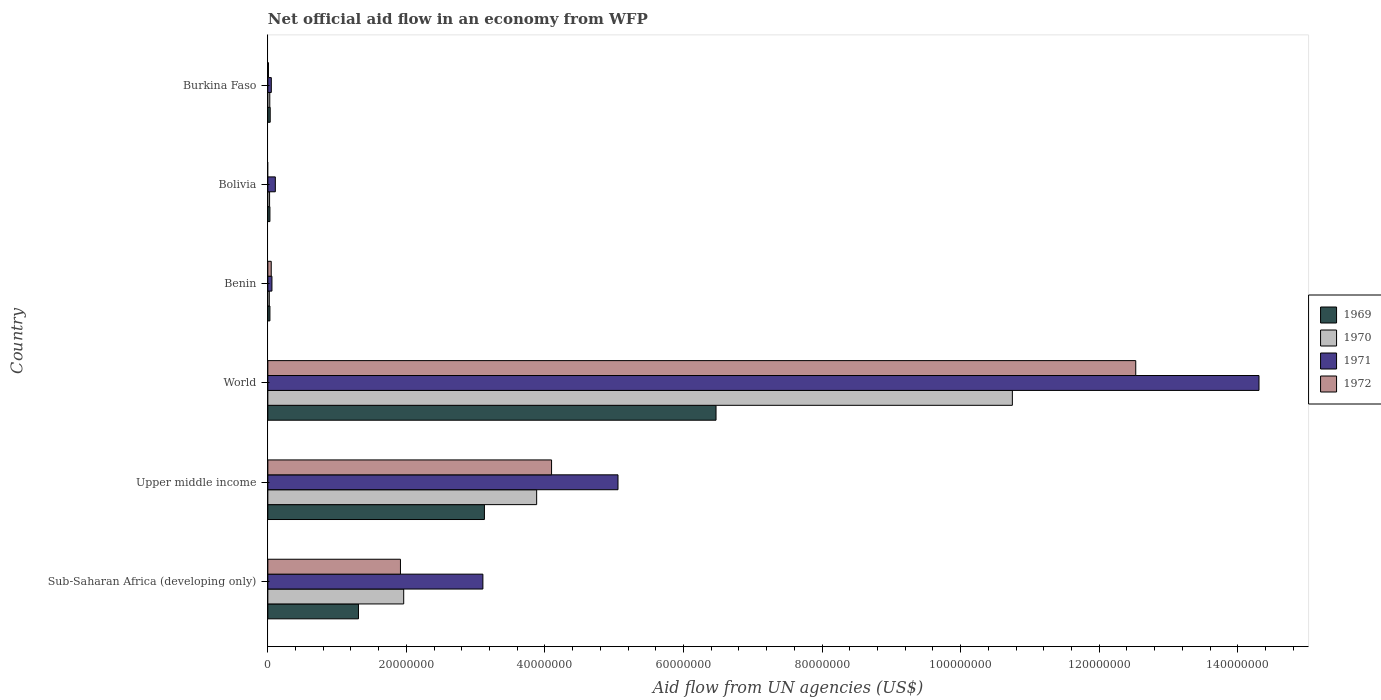How many different coloured bars are there?
Offer a very short reply. 4. How many groups of bars are there?
Provide a succinct answer. 6. Are the number of bars on each tick of the Y-axis equal?
Your answer should be compact. No. How many bars are there on the 3rd tick from the top?
Give a very brief answer. 4. How many bars are there on the 5th tick from the bottom?
Ensure brevity in your answer.  3. What is the label of the 6th group of bars from the top?
Keep it short and to the point. Sub-Saharan Africa (developing only). What is the net official aid flow in 1969 in Sub-Saharan Africa (developing only)?
Offer a very short reply. 1.31e+07. Across all countries, what is the maximum net official aid flow in 1972?
Keep it short and to the point. 1.25e+08. Across all countries, what is the minimum net official aid flow in 1972?
Your answer should be compact. 0. In which country was the net official aid flow in 1972 maximum?
Offer a very short reply. World. What is the total net official aid flow in 1972 in the graph?
Provide a short and direct response. 1.86e+08. What is the difference between the net official aid flow in 1971 in Sub-Saharan Africa (developing only) and that in World?
Your answer should be compact. -1.12e+08. What is the difference between the net official aid flow in 1971 in Bolivia and the net official aid flow in 1970 in Benin?
Ensure brevity in your answer.  8.70e+05. What is the average net official aid flow in 1972 per country?
Give a very brief answer. 3.10e+07. What is the difference between the net official aid flow in 1971 and net official aid flow in 1972 in World?
Keep it short and to the point. 1.78e+07. In how many countries, is the net official aid flow in 1969 greater than 136000000 US$?
Your answer should be compact. 0. What is the ratio of the net official aid flow in 1969 in Bolivia to that in Upper middle income?
Provide a succinct answer. 0.01. Is the net official aid flow in 1969 in Sub-Saharan Africa (developing only) less than that in Upper middle income?
Offer a very short reply. Yes. Is the difference between the net official aid flow in 1971 in Burkina Faso and Sub-Saharan Africa (developing only) greater than the difference between the net official aid flow in 1972 in Burkina Faso and Sub-Saharan Africa (developing only)?
Your answer should be compact. No. What is the difference between the highest and the second highest net official aid flow in 1969?
Your answer should be compact. 3.34e+07. What is the difference between the highest and the lowest net official aid flow in 1972?
Keep it short and to the point. 1.25e+08. How many countries are there in the graph?
Offer a very short reply. 6. What is the difference between two consecutive major ticks on the X-axis?
Provide a short and direct response. 2.00e+07. How many legend labels are there?
Your answer should be very brief. 4. How are the legend labels stacked?
Your answer should be compact. Vertical. What is the title of the graph?
Your response must be concise. Net official aid flow in an economy from WFP. Does "1963" appear as one of the legend labels in the graph?
Your answer should be very brief. No. What is the label or title of the X-axis?
Ensure brevity in your answer.  Aid flow from UN agencies (US$). What is the Aid flow from UN agencies (US$) in 1969 in Sub-Saharan Africa (developing only)?
Keep it short and to the point. 1.31e+07. What is the Aid flow from UN agencies (US$) of 1970 in Sub-Saharan Africa (developing only)?
Your answer should be compact. 1.96e+07. What is the Aid flow from UN agencies (US$) of 1971 in Sub-Saharan Africa (developing only)?
Offer a terse response. 3.10e+07. What is the Aid flow from UN agencies (US$) of 1972 in Sub-Saharan Africa (developing only)?
Make the answer very short. 1.91e+07. What is the Aid flow from UN agencies (US$) in 1969 in Upper middle income?
Keep it short and to the point. 3.13e+07. What is the Aid flow from UN agencies (US$) of 1970 in Upper middle income?
Ensure brevity in your answer.  3.88e+07. What is the Aid flow from UN agencies (US$) in 1971 in Upper middle income?
Your answer should be compact. 5.05e+07. What is the Aid flow from UN agencies (US$) in 1972 in Upper middle income?
Offer a very short reply. 4.10e+07. What is the Aid flow from UN agencies (US$) of 1969 in World?
Your answer should be very brief. 6.47e+07. What is the Aid flow from UN agencies (US$) in 1970 in World?
Your answer should be compact. 1.07e+08. What is the Aid flow from UN agencies (US$) in 1971 in World?
Your answer should be very brief. 1.43e+08. What is the Aid flow from UN agencies (US$) of 1972 in World?
Give a very brief answer. 1.25e+08. What is the Aid flow from UN agencies (US$) of 1970 in Benin?
Make the answer very short. 2.10e+05. What is the Aid flow from UN agencies (US$) in 1971 in Benin?
Provide a short and direct response. 5.90e+05. What is the Aid flow from UN agencies (US$) of 1970 in Bolivia?
Your response must be concise. 2.50e+05. What is the Aid flow from UN agencies (US$) of 1971 in Bolivia?
Offer a very short reply. 1.08e+06. What is the Aid flow from UN agencies (US$) of 1972 in Bolivia?
Give a very brief answer. 0. What is the Aid flow from UN agencies (US$) in 1969 in Burkina Faso?
Offer a terse response. 3.40e+05. What is the Aid flow from UN agencies (US$) in 1971 in Burkina Faso?
Provide a short and direct response. 5.00e+05. Across all countries, what is the maximum Aid flow from UN agencies (US$) of 1969?
Your answer should be compact. 6.47e+07. Across all countries, what is the maximum Aid flow from UN agencies (US$) of 1970?
Keep it short and to the point. 1.07e+08. Across all countries, what is the maximum Aid flow from UN agencies (US$) of 1971?
Ensure brevity in your answer.  1.43e+08. Across all countries, what is the maximum Aid flow from UN agencies (US$) of 1972?
Ensure brevity in your answer.  1.25e+08. What is the total Aid flow from UN agencies (US$) of 1969 in the graph?
Your response must be concise. 1.10e+08. What is the total Aid flow from UN agencies (US$) of 1970 in the graph?
Provide a succinct answer. 1.67e+08. What is the total Aid flow from UN agencies (US$) of 1971 in the graph?
Provide a succinct answer. 2.27e+08. What is the total Aid flow from UN agencies (US$) of 1972 in the graph?
Offer a very short reply. 1.86e+08. What is the difference between the Aid flow from UN agencies (US$) of 1969 in Sub-Saharan Africa (developing only) and that in Upper middle income?
Ensure brevity in your answer.  -1.82e+07. What is the difference between the Aid flow from UN agencies (US$) of 1970 in Sub-Saharan Africa (developing only) and that in Upper middle income?
Keep it short and to the point. -1.92e+07. What is the difference between the Aid flow from UN agencies (US$) of 1971 in Sub-Saharan Africa (developing only) and that in Upper middle income?
Ensure brevity in your answer.  -1.95e+07. What is the difference between the Aid flow from UN agencies (US$) of 1972 in Sub-Saharan Africa (developing only) and that in Upper middle income?
Ensure brevity in your answer.  -2.18e+07. What is the difference between the Aid flow from UN agencies (US$) of 1969 in Sub-Saharan Africa (developing only) and that in World?
Give a very brief answer. -5.16e+07. What is the difference between the Aid flow from UN agencies (US$) in 1970 in Sub-Saharan Africa (developing only) and that in World?
Give a very brief answer. -8.78e+07. What is the difference between the Aid flow from UN agencies (US$) of 1971 in Sub-Saharan Africa (developing only) and that in World?
Offer a terse response. -1.12e+08. What is the difference between the Aid flow from UN agencies (US$) in 1972 in Sub-Saharan Africa (developing only) and that in World?
Provide a succinct answer. -1.06e+08. What is the difference between the Aid flow from UN agencies (US$) in 1969 in Sub-Saharan Africa (developing only) and that in Benin?
Offer a very short reply. 1.28e+07. What is the difference between the Aid flow from UN agencies (US$) of 1970 in Sub-Saharan Africa (developing only) and that in Benin?
Keep it short and to the point. 1.94e+07. What is the difference between the Aid flow from UN agencies (US$) of 1971 in Sub-Saharan Africa (developing only) and that in Benin?
Keep it short and to the point. 3.04e+07. What is the difference between the Aid flow from UN agencies (US$) in 1972 in Sub-Saharan Africa (developing only) and that in Benin?
Ensure brevity in your answer.  1.86e+07. What is the difference between the Aid flow from UN agencies (US$) of 1969 in Sub-Saharan Africa (developing only) and that in Bolivia?
Keep it short and to the point. 1.28e+07. What is the difference between the Aid flow from UN agencies (US$) of 1970 in Sub-Saharan Africa (developing only) and that in Bolivia?
Offer a very short reply. 1.94e+07. What is the difference between the Aid flow from UN agencies (US$) in 1971 in Sub-Saharan Africa (developing only) and that in Bolivia?
Provide a short and direct response. 3.00e+07. What is the difference between the Aid flow from UN agencies (US$) of 1969 in Sub-Saharan Africa (developing only) and that in Burkina Faso?
Your response must be concise. 1.27e+07. What is the difference between the Aid flow from UN agencies (US$) in 1970 in Sub-Saharan Africa (developing only) and that in Burkina Faso?
Keep it short and to the point. 1.93e+07. What is the difference between the Aid flow from UN agencies (US$) in 1971 in Sub-Saharan Africa (developing only) and that in Burkina Faso?
Your answer should be very brief. 3.05e+07. What is the difference between the Aid flow from UN agencies (US$) of 1972 in Sub-Saharan Africa (developing only) and that in Burkina Faso?
Provide a short and direct response. 1.90e+07. What is the difference between the Aid flow from UN agencies (US$) in 1969 in Upper middle income and that in World?
Your answer should be compact. -3.34e+07. What is the difference between the Aid flow from UN agencies (US$) in 1970 in Upper middle income and that in World?
Make the answer very short. -6.87e+07. What is the difference between the Aid flow from UN agencies (US$) in 1971 in Upper middle income and that in World?
Make the answer very short. -9.25e+07. What is the difference between the Aid flow from UN agencies (US$) in 1972 in Upper middle income and that in World?
Offer a terse response. -8.43e+07. What is the difference between the Aid flow from UN agencies (US$) of 1969 in Upper middle income and that in Benin?
Give a very brief answer. 3.10e+07. What is the difference between the Aid flow from UN agencies (US$) in 1970 in Upper middle income and that in Benin?
Your answer should be very brief. 3.86e+07. What is the difference between the Aid flow from UN agencies (US$) of 1971 in Upper middle income and that in Benin?
Offer a terse response. 5.00e+07. What is the difference between the Aid flow from UN agencies (US$) in 1972 in Upper middle income and that in Benin?
Give a very brief answer. 4.05e+07. What is the difference between the Aid flow from UN agencies (US$) of 1969 in Upper middle income and that in Bolivia?
Your response must be concise. 3.10e+07. What is the difference between the Aid flow from UN agencies (US$) in 1970 in Upper middle income and that in Bolivia?
Give a very brief answer. 3.86e+07. What is the difference between the Aid flow from UN agencies (US$) in 1971 in Upper middle income and that in Bolivia?
Offer a very short reply. 4.95e+07. What is the difference between the Aid flow from UN agencies (US$) of 1969 in Upper middle income and that in Burkina Faso?
Offer a terse response. 3.09e+07. What is the difference between the Aid flow from UN agencies (US$) in 1970 in Upper middle income and that in Burkina Faso?
Offer a terse response. 3.85e+07. What is the difference between the Aid flow from UN agencies (US$) of 1971 in Upper middle income and that in Burkina Faso?
Provide a short and direct response. 5.00e+07. What is the difference between the Aid flow from UN agencies (US$) in 1972 in Upper middle income and that in Burkina Faso?
Give a very brief answer. 4.09e+07. What is the difference between the Aid flow from UN agencies (US$) of 1969 in World and that in Benin?
Provide a succinct answer. 6.44e+07. What is the difference between the Aid flow from UN agencies (US$) of 1970 in World and that in Benin?
Offer a terse response. 1.07e+08. What is the difference between the Aid flow from UN agencies (US$) in 1971 in World and that in Benin?
Provide a succinct answer. 1.42e+08. What is the difference between the Aid flow from UN agencies (US$) in 1972 in World and that in Benin?
Your answer should be very brief. 1.25e+08. What is the difference between the Aid flow from UN agencies (US$) of 1969 in World and that in Bolivia?
Keep it short and to the point. 6.44e+07. What is the difference between the Aid flow from UN agencies (US$) of 1970 in World and that in Bolivia?
Give a very brief answer. 1.07e+08. What is the difference between the Aid flow from UN agencies (US$) of 1971 in World and that in Bolivia?
Your answer should be compact. 1.42e+08. What is the difference between the Aid flow from UN agencies (US$) in 1969 in World and that in Burkina Faso?
Give a very brief answer. 6.44e+07. What is the difference between the Aid flow from UN agencies (US$) of 1970 in World and that in Burkina Faso?
Ensure brevity in your answer.  1.07e+08. What is the difference between the Aid flow from UN agencies (US$) in 1971 in World and that in Burkina Faso?
Give a very brief answer. 1.43e+08. What is the difference between the Aid flow from UN agencies (US$) of 1972 in World and that in Burkina Faso?
Give a very brief answer. 1.25e+08. What is the difference between the Aid flow from UN agencies (US$) in 1970 in Benin and that in Bolivia?
Your response must be concise. -4.00e+04. What is the difference between the Aid flow from UN agencies (US$) in 1971 in Benin and that in Bolivia?
Ensure brevity in your answer.  -4.90e+05. What is the difference between the Aid flow from UN agencies (US$) of 1970 in Benin and that in Burkina Faso?
Your answer should be compact. -7.00e+04. What is the difference between the Aid flow from UN agencies (US$) in 1971 in Benin and that in Burkina Faso?
Offer a terse response. 9.00e+04. What is the difference between the Aid flow from UN agencies (US$) of 1969 in Bolivia and that in Burkina Faso?
Your response must be concise. -4.00e+04. What is the difference between the Aid flow from UN agencies (US$) in 1970 in Bolivia and that in Burkina Faso?
Offer a terse response. -3.00e+04. What is the difference between the Aid flow from UN agencies (US$) in 1971 in Bolivia and that in Burkina Faso?
Your answer should be compact. 5.80e+05. What is the difference between the Aid flow from UN agencies (US$) in 1969 in Sub-Saharan Africa (developing only) and the Aid flow from UN agencies (US$) in 1970 in Upper middle income?
Offer a very short reply. -2.57e+07. What is the difference between the Aid flow from UN agencies (US$) of 1969 in Sub-Saharan Africa (developing only) and the Aid flow from UN agencies (US$) of 1971 in Upper middle income?
Your response must be concise. -3.75e+07. What is the difference between the Aid flow from UN agencies (US$) of 1969 in Sub-Saharan Africa (developing only) and the Aid flow from UN agencies (US$) of 1972 in Upper middle income?
Provide a succinct answer. -2.79e+07. What is the difference between the Aid flow from UN agencies (US$) in 1970 in Sub-Saharan Africa (developing only) and the Aid flow from UN agencies (US$) in 1971 in Upper middle income?
Provide a succinct answer. -3.09e+07. What is the difference between the Aid flow from UN agencies (US$) of 1970 in Sub-Saharan Africa (developing only) and the Aid flow from UN agencies (US$) of 1972 in Upper middle income?
Give a very brief answer. -2.13e+07. What is the difference between the Aid flow from UN agencies (US$) of 1971 in Sub-Saharan Africa (developing only) and the Aid flow from UN agencies (US$) of 1972 in Upper middle income?
Provide a short and direct response. -9.91e+06. What is the difference between the Aid flow from UN agencies (US$) in 1969 in Sub-Saharan Africa (developing only) and the Aid flow from UN agencies (US$) in 1970 in World?
Keep it short and to the point. -9.44e+07. What is the difference between the Aid flow from UN agencies (US$) in 1969 in Sub-Saharan Africa (developing only) and the Aid flow from UN agencies (US$) in 1971 in World?
Provide a short and direct response. -1.30e+08. What is the difference between the Aid flow from UN agencies (US$) of 1969 in Sub-Saharan Africa (developing only) and the Aid flow from UN agencies (US$) of 1972 in World?
Offer a very short reply. -1.12e+08. What is the difference between the Aid flow from UN agencies (US$) in 1970 in Sub-Saharan Africa (developing only) and the Aid flow from UN agencies (US$) in 1971 in World?
Give a very brief answer. -1.23e+08. What is the difference between the Aid flow from UN agencies (US$) of 1970 in Sub-Saharan Africa (developing only) and the Aid flow from UN agencies (US$) of 1972 in World?
Provide a short and direct response. -1.06e+08. What is the difference between the Aid flow from UN agencies (US$) of 1971 in Sub-Saharan Africa (developing only) and the Aid flow from UN agencies (US$) of 1972 in World?
Offer a very short reply. -9.42e+07. What is the difference between the Aid flow from UN agencies (US$) of 1969 in Sub-Saharan Africa (developing only) and the Aid flow from UN agencies (US$) of 1970 in Benin?
Provide a short and direct response. 1.29e+07. What is the difference between the Aid flow from UN agencies (US$) in 1969 in Sub-Saharan Africa (developing only) and the Aid flow from UN agencies (US$) in 1971 in Benin?
Provide a short and direct response. 1.25e+07. What is the difference between the Aid flow from UN agencies (US$) of 1969 in Sub-Saharan Africa (developing only) and the Aid flow from UN agencies (US$) of 1972 in Benin?
Your response must be concise. 1.26e+07. What is the difference between the Aid flow from UN agencies (US$) in 1970 in Sub-Saharan Africa (developing only) and the Aid flow from UN agencies (US$) in 1971 in Benin?
Provide a succinct answer. 1.90e+07. What is the difference between the Aid flow from UN agencies (US$) of 1970 in Sub-Saharan Africa (developing only) and the Aid flow from UN agencies (US$) of 1972 in Benin?
Ensure brevity in your answer.  1.91e+07. What is the difference between the Aid flow from UN agencies (US$) of 1971 in Sub-Saharan Africa (developing only) and the Aid flow from UN agencies (US$) of 1972 in Benin?
Your answer should be compact. 3.06e+07. What is the difference between the Aid flow from UN agencies (US$) in 1969 in Sub-Saharan Africa (developing only) and the Aid flow from UN agencies (US$) in 1970 in Bolivia?
Offer a very short reply. 1.28e+07. What is the difference between the Aid flow from UN agencies (US$) in 1969 in Sub-Saharan Africa (developing only) and the Aid flow from UN agencies (US$) in 1971 in Bolivia?
Provide a short and direct response. 1.20e+07. What is the difference between the Aid flow from UN agencies (US$) of 1970 in Sub-Saharan Africa (developing only) and the Aid flow from UN agencies (US$) of 1971 in Bolivia?
Your answer should be compact. 1.85e+07. What is the difference between the Aid flow from UN agencies (US$) of 1969 in Sub-Saharan Africa (developing only) and the Aid flow from UN agencies (US$) of 1970 in Burkina Faso?
Your response must be concise. 1.28e+07. What is the difference between the Aid flow from UN agencies (US$) in 1969 in Sub-Saharan Africa (developing only) and the Aid flow from UN agencies (US$) in 1971 in Burkina Faso?
Offer a very short reply. 1.26e+07. What is the difference between the Aid flow from UN agencies (US$) of 1969 in Sub-Saharan Africa (developing only) and the Aid flow from UN agencies (US$) of 1972 in Burkina Faso?
Keep it short and to the point. 1.30e+07. What is the difference between the Aid flow from UN agencies (US$) in 1970 in Sub-Saharan Africa (developing only) and the Aid flow from UN agencies (US$) in 1971 in Burkina Faso?
Provide a short and direct response. 1.91e+07. What is the difference between the Aid flow from UN agencies (US$) in 1970 in Sub-Saharan Africa (developing only) and the Aid flow from UN agencies (US$) in 1972 in Burkina Faso?
Make the answer very short. 1.95e+07. What is the difference between the Aid flow from UN agencies (US$) of 1971 in Sub-Saharan Africa (developing only) and the Aid flow from UN agencies (US$) of 1972 in Burkina Faso?
Offer a terse response. 3.10e+07. What is the difference between the Aid flow from UN agencies (US$) of 1969 in Upper middle income and the Aid flow from UN agencies (US$) of 1970 in World?
Make the answer very short. -7.62e+07. What is the difference between the Aid flow from UN agencies (US$) of 1969 in Upper middle income and the Aid flow from UN agencies (US$) of 1971 in World?
Keep it short and to the point. -1.12e+08. What is the difference between the Aid flow from UN agencies (US$) of 1969 in Upper middle income and the Aid flow from UN agencies (US$) of 1972 in World?
Make the answer very short. -9.40e+07. What is the difference between the Aid flow from UN agencies (US$) in 1970 in Upper middle income and the Aid flow from UN agencies (US$) in 1971 in World?
Give a very brief answer. -1.04e+08. What is the difference between the Aid flow from UN agencies (US$) in 1970 in Upper middle income and the Aid flow from UN agencies (US$) in 1972 in World?
Your response must be concise. -8.65e+07. What is the difference between the Aid flow from UN agencies (US$) in 1971 in Upper middle income and the Aid flow from UN agencies (US$) in 1972 in World?
Your answer should be very brief. -7.47e+07. What is the difference between the Aid flow from UN agencies (US$) in 1969 in Upper middle income and the Aid flow from UN agencies (US$) in 1970 in Benin?
Provide a short and direct response. 3.10e+07. What is the difference between the Aid flow from UN agencies (US$) in 1969 in Upper middle income and the Aid flow from UN agencies (US$) in 1971 in Benin?
Keep it short and to the point. 3.07e+07. What is the difference between the Aid flow from UN agencies (US$) in 1969 in Upper middle income and the Aid flow from UN agencies (US$) in 1972 in Benin?
Your answer should be very brief. 3.08e+07. What is the difference between the Aid flow from UN agencies (US$) in 1970 in Upper middle income and the Aid flow from UN agencies (US$) in 1971 in Benin?
Ensure brevity in your answer.  3.82e+07. What is the difference between the Aid flow from UN agencies (US$) in 1970 in Upper middle income and the Aid flow from UN agencies (US$) in 1972 in Benin?
Provide a short and direct response. 3.83e+07. What is the difference between the Aid flow from UN agencies (US$) of 1971 in Upper middle income and the Aid flow from UN agencies (US$) of 1972 in Benin?
Make the answer very short. 5.00e+07. What is the difference between the Aid flow from UN agencies (US$) of 1969 in Upper middle income and the Aid flow from UN agencies (US$) of 1970 in Bolivia?
Your answer should be very brief. 3.10e+07. What is the difference between the Aid flow from UN agencies (US$) in 1969 in Upper middle income and the Aid flow from UN agencies (US$) in 1971 in Bolivia?
Your answer should be compact. 3.02e+07. What is the difference between the Aid flow from UN agencies (US$) in 1970 in Upper middle income and the Aid flow from UN agencies (US$) in 1971 in Bolivia?
Your answer should be very brief. 3.77e+07. What is the difference between the Aid flow from UN agencies (US$) of 1969 in Upper middle income and the Aid flow from UN agencies (US$) of 1970 in Burkina Faso?
Ensure brevity in your answer.  3.10e+07. What is the difference between the Aid flow from UN agencies (US$) in 1969 in Upper middle income and the Aid flow from UN agencies (US$) in 1971 in Burkina Faso?
Make the answer very short. 3.08e+07. What is the difference between the Aid flow from UN agencies (US$) in 1969 in Upper middle income and the Aid flow from UN agencies (US$) in 1972 in Burkina Faso?
Keep it short and to the point. 3.12e+07. What is the difference between the Aid flow from UN agencies (US$) in 1970 in Upper middle income and the Aid flow from UN agencies (US$) in 1971 in Burkina Faso?
Offer a very short reply. 3.83e+07. What is the difference between the Aid flow from UN agencies (US$) in 1970 in Upper middle income and the Aid flow from UN agencies (US$) in 1972 in Burkina Faso?
Make the answer very short. 3.87e+07. What is the difference between the Aid flow from UN agencies (US$) of 1971 in Upper middle income and the Aid flow from UN agencies (US$) of 1972 in Burkina Faso?
Offer a terse response. 5.04e+07. What is the difference between the Aid flow from UN agencies (US$) in 1969 in World and the Aid flow from UN agencies (US$) in 1970 in Benin?
Your response must be concise. 6.45e+07. What is the difference between the Aid flow from UN agencies (US$) in 1969 in World and the Aid flow from UN agencies (US$) in 1971 in Benin?
Give a very brief answer. 6.41e+07. What is the difference between the Aid flow from UN agencies (US$) in 1969 in World and the Aid flow from UN agencies (US$) in 1972 in Benin?
Your answer should be very brief. 6.42e+07. What is the difference between the Aid flow from UN agencies (US$) of 1970 in World and the Aid flow from UN agencies (US$) of 1971 in Benin?
Your answer should be very brief. 1.07e+08. What is the difference between the Aid flow from UN agencies (US$) of 1970 in World and the Aid flow from UN agencies (US$) of 1972 in Benin?
Provide a succinct answer. 1.07e+08. What is the difference between the Aid flow from UN agencies (US$) in 1971 in World and the Aid flow from UN agencies (US$) in 1972 in Benin?
Offer a very short reply. 1.43e+08. What is the difference between the Aid flow from UN agencies (US$) of 1969 in World and the Aid flow from UN agencies (US$) of 1970 in Bolivia?
Your response must be concise. 6.44e+07. What is the difference between the Aid flow from UN agencies (US$) in 1969 in World and the Aid flow from UN agencies (US$) in 1971 in Bolivia?
Offer a very short reply. 6.36e+07. What is the difference between the Aid flow from UN agencies (US$) in 1970 in World and the Aid flow from UN agencies (US$) in 1971 in Bolivia?
Offer a very short reply. 1.06e+08. What is the difference between the Aid flow from UN agencies (US$) of 1969 in World and the Aid flow from UN agencies (US$) of 1970 in Burkina Faso?
Provide a succinct answer. 6.44e+07. What is the difference between the Aid flow from UN agencies (US$) of 1969 in World and the Aid flow from UN agencies (US$) of 1971 in Burkina Faso?
Offer a terse response. 6.42e+07. What is the difference between the Aid flow from UN agencies (US$) of 1969 in World and the Aid flow from UN agencies (US$) of 1972 in Burkina Faso?
Keep it short and to the point. 6.46e+07. What is the difference between the Aid flow from UN agencies (US$) in 1970 in World and the Aid flow from UN agencies (US$) in 1971 in Burkina Faso?
Offer a very short reply. 1.07e+08. What is the difference between the Aid flow from UN agencies (US$) in 1970 in World and the Aid flow from UN agencies (US$) in 1972 in Burkina Faso?
Keep it short and to the point. 1.07e+08. What is the difference between the Aid flow from UN agencies (US$) in 1971 in World and the Aid flow from UN agencies (US$) in 1972 in Burkina Faso?
Offer a very short reply. 1.43e+08. What is the difference between the Aid flow from UN agencies (US$) of 1969 in Benin and the Aid flow from UN agencies (US$) of 1970 in Bolivia?
Provide a short and direct response. 5.00e+04. What is the difference between the Aid flow from UN agencies (US$) of 1969 in Benin and the Aid flow from UN agencies (US$) of 1971 in Bolivia?
Offer a very short reply. -7.80e+05. What is the difference between the Aid flow from UN agencies (US$) of 1970 in Benin and the Aid flow from UN agencies (US$) of 1971 in Bolivia?
Offer a terse response. -8.70e+05. What is the difference between the Aid flow from UN agencies (US$) of 1969 in Benin and the Aid flow from UN agencies (US$) of 1970 in Burkina Faso?
Your answer should be compact. 2.00e+04. What is the difference between the Aid flow from UN agencies (US$) of 1969 in Benin and the Aid flow from UN agencies (US$) of 1971 in Burkina Faso?
Offer a very short reply. -2.00e+05. What is the difference between the Aid flow from UN agencies (US$) of 1969 in Benin and the Aid flow from UN agencies (US$) of 1972 in Burkina Faso?
Provide a succinct answer. 2.10e+05. What is the difference between the Aid flow from UN agencies (US$) in 1970 in Benin and the Aid flow from UN agencies (US$) in 1971 in Burkina Faso?
Give a very brief answer. -2.90e+05. What is the difference between the Aid flow from UN agencies (US$) of 1970 in Benin and the Aid flow from UN agencies (US$) of 1972 in Burkina Faso?
Your response must be concise. 1.20e+05. What is the difference between the Aid flow from UN agencies (US$) in 1969 in Bolivia and the Aid flow from UN agencies (US$) in 1972 in Burkina Faso?
Ensure brevity in your answer.  2.10e+05. What is the difference between the Aid flow from UN agencies (US$) of 1971 in Bolivia and the Aid flow from UN agencies (US$) of 1972 in Burkina Faso?
Your answer should be very brief. 9.90e+05. What is the average Aid flow from UN agencies (US$) in 1969 per country?
Provide a short and direct response. 1.83e+07. What is the average Aid flow from UN agencies (US$) in 1970 per country?
Your response must be concise. 2.78e+07. What is the average Aid flow from UN agencies (US$) in 1971 per country?
Your answer should be compact. 3.78e+07. What is the average Aid flow from UN agencies (US$) of 1972 per country?
Ensure brevity in your answer.  3.10e+07. What is the difference between the Aid flow from UN agencies (US$) of 1969 and Aid flow from UN agencies (US$) of 1970 in Sub-Saharan Africa (developing only)?
Ensure brevity in your answer.  -6.53e+06. What is the difference between the Aid flow from UN agencies (US$) in 1969 and Aid flow from UN agencies (US$) in 1971 in Sub-Saharan Africa (developing only)?
Provide a short and direct response. -1.80e+07. What is the difference between the Aid flow from UN agencies (US$) in 1969 and Aid flow from UN agencies (US$) in 1972 in Sub-Saharan Africa (developing only)?
Provide a succinct answer. -6.06e+06. What is the difference between the Aid flow from UN agencies (US$) in 1970 and Aid flow from UN agencies (US$) in 1971 in Sub-Saharan Africa (developing only)?
Keep it short and to the point. -1.14e+07. What is the difference between the Aid flow from UN agencies (US$) of 1970 and Aid flow from UN agencies (US$) of 1972 in Sub-Saharan Africa (developing only)?
Make the answer very short. 4.70e+05. What is the difference between the Aid flow from UN agencies (US$) in 1971 and Aid flow from UN agencies (US$) in 1972 in Sub-Saharan Africa (developing only)?
Keep it short and to the point. 1.19e+07. What is the difference between the Aid flow from UN agencies (US$) of 1969 and Aid flow from UN agencies (US$) of 1970 in Upper middle income?
Ensure brevity in your answer.  -7.54e+06. What is the difference between the Aid flow from UN agencies (US$) in 1969 and Aid flow from UN agencies (US$) in 1971 in Upper middle income?
Make the answer very short. -1.93e+07. What is the difference between the Aid flow from UN agencies (US$) in 1969 and Aid flow from UN agencies (US$) in 1972 in Upper middle income?
Offer a very short reply. -9.69e+06. What is the difference between the Aid flow from UN agencies (US$) in 1970 and Aid flow from UN agencies (US$) in 1971 in Upper middle income?
Offer a very short reply. -1.17e+07. What is the difference between the Aid flow from UN agencies (US$) in 1970 and Aid flow from UN agencies (US$) in 1972 in Upper middle income?
Your answer should be compact. -2.15e+06. What is the difference between the Aid flow from UN agencies (US$) of 1971 and Aid flow from UN agencies (US$) of 1972 in Upper middle income?
Provide a short and direct response. 9.59e+06. What is the difference between the Aid flow from UN agencies (US$) in 1969 and Aid flow from UN agencies (US$) in 1970 in World?
Provide a short and direct response. -4.28e+07. What is the difference between the Aid flow from UN agencies (US$) in 1969 and Aid flow from UN agencies (US$) in 1971 in World?
Offer a terse response. -7.84e+07. What is the difference between the Aid flow from UN agencies (US$) of 1969 and Aid flow from UN agencies (US$) of 1972 in World?
Your answer should be compact. -6.06e+07. What is the difference between the Aid flow from UN agencies (US$) in 1970 and Aid flow from UN agencies (US$) in 1971 in World?
Offer a very short reply. -3.56e+07. What is the difference between the Aid flow from UN agencies (US$) of 1970 and Aid flow from UN agencies (US$) of 1972 in World?
Your answer should be compact. -1.78e+07. What is the difference between the Aid flow from UN agencies (US$) of 1971 and Aid flow from UN agencies (US$) of 1972 in World?
Provide a short and direct response. 1.78e+07. What is the difference between the Aid flow from UN agencies (US$) of 1969 and Aid flow from UN agencies (US$) of 1971 in Benin?
Make the answer very short. -2.90e+05. What is the difference between the Aid flow from UN agencies (US$) of 1970 and Aid flow from UN agencies (US$) of 1971 in Benin?
Provide a succinct answer. -3.80e+05. What is the difference between the Aid flow from UN agencies (US$) in 1970 and Aid flow from UN agencies (US$) in 1972 in Benin?
Ensure brevity in your answer.  -2.80e+05. What is the difference between the Aid flow from UN agencies (US$) in 1971 and Aid flow from UN agencies (US$) in 1972 in Benin?
Offer a very short reply. 1.00e+05. What is the difference between the Aid flow from UN agencies (US$) of 1969 and Aid flow from UN agencies (US$) of 1971 in Bolivia?
Provide a succinct answer. -7.80e+05. What is the difference between the Aid flow from UN agencies (US$) of 1970 and Aid flow from UN agencies (US$) of 1971 in Bolivia?
Offer a terse response. -8.30e+05. What is the difference between the Aid flow from UN agencies (US$) in 1970 and Aid flow from UN agencies (US$) in 1971 in Burkina Faso?
Provide a short and direct response. -2.20e+05. What is the difference between the Aid flow from UN agencies (US$) of 1970 and Aid flow from UN agencies (US$) of 1972 in Burkina Faso?
Offer a very short reply. 1.90e+05. What is the ratio of the Aid flow from UN agencies (US$) of 1969 in Sub-Saharan Africa (developing only) to that in Upper middle income?
Ensure brevity in your answer.  0.42. What is the ratio of the Aid flow from UN agencies (US$) in 1970 in Sub-Saharan Africa (developing only) to that in Upper middle income?
Provide a short and direct response. 0.51. What is the ratio of the Aid flow from UN agencies (US$) of 1971 in Sub-Saharan Africa (developing only) to that in Upper middle income?
Give a very brief answer. 0.61. What is the ratio of the Aid flow from UN agencies (US$) of 1972 in Sub-Saharan Africa (developing only) to that in Upper middle income?
Your answer should be very brief. 0.47. What is the ratio of the Aid flow from UN agencies (US$) of 1969 in Sub-Saharan Africa (developing only) to that in World?
Your response must be concise. 0.2. What is the ratio of the Aid flow from UN agencies (US$) of 1970 in Sub-Saharan Africa (developing only) to that in World?
Keep it short and to the point. 0.18. What is the ratio of the Aid flow from UN agencies (US$) of 1971 in Sub-Saharan Africa (developing only) to that in World?
Your answer should be compact. 0.22. What is the ratio of the Aid flow from UN agencies (US$) of 1972 in Sub-Saharan Africa (developing only) to that in World?
Offer a terse response. 0.15. What is the ratio of the Aid flow from UN agencies (US$) of 1969 in Sub-Saharan Africa (developing only) to that in Benin?
Your answer should be very brief. 43.6. What is the ratio of the Aid flow from UN agencies (US$) of 1970 in Sub-Saharan Africa (developing only) to that in Benin?
Provide a short and direct response. 93.38. What is the ratio of the Aid flow from UN agencies (US$) of 1971 in Sub-Saharan Africa (developing only) to that in Benin?
Make the answer very short. 52.61. What is the ratio of the Aid flow from UN agencies (US$) of 1972 in Sub-Saharan Africa (developing only) to that in Benin?
Your answer should be compact. 39.06. What is the ratio of the Aid flow from UN agencies (US$) of 1969 in Sub-Saharan Africa (developing only) to that in Bolivia?
Your response must be concise. 43.6. What is the ratio of the Aid flow from UN agencies (US$) of 1970 in Sub-Saharan Africa (developing only) to that in Bolivia?
Offer a terse response. 78.44. What is the ratio of the Aid flow from UN agencies (US$) of 1971 in Sub-Saharan Africa (developing only) to that in Bolivia?
Make the answer very short. 28.74. What is the ratio of the Aid flow from UN agencies (US$) of 1969 in Sub-Saharan Africa (developing only) to that in Burkina Faso?
Provide a short and direct response. 38.47. What is the ratio of the Aid flow from UN agencies (US$) of 1970 in Sub-Saharan Africa (developing only) to that in Burkina Faso?
Make the answer very short. 70.04. What is the ratio of the Aid flow from UN agencies (US$) of 1971 in Sub-Saharan Africa (developing only) to that in Burkina Faso?
Keep it short and to the point. 62.08. What is the ratio of the Aid flow from UN agencies (US$) in 1972 in Sub-Saharan Africa (developing only) to that in Burkina Faso?
Your response must be concise. 212.67. What is the ratio of the Aid flow from UN agencies (US$) in 1969 in Upper middle income to that in World?
Offer a terse response. 0.48. What is the ratio of the Aid flow from UN agencies (US$) of 1970 in Upper middle income to that in World?
Your answer should be very brief. 0.36. What is the ratio of the Aid flow from UN agencies (US$) of 1971 in Upper middle income to that in World?
Offer a terse response. 0.35. What is the ratio of the Aid flow from UN agencies (US$) in 1972 in Upper middle income to that in World?
Give a very brief answer. 0.33. What is the ratio of the Aid flow from UN agencies (US$) in 1969 in Upper middle income to that in Benin?
Your answer should be very brief. 104.2. What is the ratio of the Aid flow from UN agencies (US$) in 1970 in Upper middle income to that in Benin?
Your answer should be very brief. 184.76. What is the ratio of the Aid flow from UN agencies (US$) in 1971 in Upper middle income to that in Benin?
Offer a terse response. 85.66. What is the ratio of the Aid flow from UN agencies (US$) of 1972 in Upper middle income to that in Benin?
Make the answer very short. 83.57. What is the ratio of the Aid flow from UN agencies (US$) of 1969 in Upper middle income to that in Bolivia?
Ensure brevity in your answer.  104.2. What is the ratio of the Aid flow from UN agencies (US$) in 1970 in Upper middle income to that in Bolivia?
Keep it short and to the point. 155.2. What is the ratio of the Aid flow from UN agencies (US$) of 1971 in Upper middle income to that in Bolivia?
Offer a very short reply. 46.8. What is the ratio of the Aid flow from UN agencies (US$) in 1969 in Upper middle income to that in Burkina Faso?
Give a very brief answer. 91.94. What is the ratio of the Aid flow from UN agencies (US$) of 1970 in Upper middle income to that in Burkina Faso?
Give a very brief answer. 138.57. What is the ratio of the Aid flow from UN agencies (US$) of 1971 in Upper middle income to that in Burkina Faso?
Offer a very short reply. 101.08. What is the ratio of the Aid flow from UN agencies (US$) in 1972 in Upper middle income to that in Burkina Faso?
Keep it short and to the point. 455. What is the ratio of the Aid flow from UN agencies (US$) of 1969 in World to that in Benin?
Provide a short and direct response. 215.63. What is the ratio of the Aid flow from UN agencies (US$) of 1970 in World to that in Benin?
Provide a succinct answer. 511.71. What is the ratio of the Aid flow from UN agencies (US$) in 1971 in World to that in Benin?
Keep it short and to the point. 242.47. What is the ratio of the Aid flow from UN agencies (US$) of 1972 in World to that in Benin?
Give a very brief answer. 255.65. What is the ratio of the Aid flow from UN agencies (US$) in 1969 in World to that in Bolivia?
Provide a succinct answer. 215.63. What is the ratio of the Aid flow from UN agencies (US$) in 1970 in World to that in Bolivia?
Make the answer very short. 429.84. What is the ratio of the Aid flow from UN agencies (US$) of 1971 in World to that in Bolivia?
Give a very brief answer. 132.46. What is the ratio of the Aid flow from UN agencies (US$) in 1969 in World to that in Burkina Faso?
Provide a short and direct response. 190.26. What is the ratio of the Aid flow from UN agencies (US$) in 1970 in World to that in Burkina Faso?
Your answer should be compact. 383.79. What is the ratio of the Aid flow from UN agencies (US$) of 1971 in World to that in Burkina Faso?
Your response must be concise. 286.12. What is the ratio of the Aid flow from UN agencies (US$) in 1972 in World to that in Burkina Faso?
Offer a terse response. 1391.89. What is the ratio of the Aid flow from UN agencies (US$) in 1970 in Benin to that in Bolivia?
Your answer should be compact. 0.84. What is the ratio of the Aid flow from UN agencies (US$) of 1971 in Benin to that in Bolivia?
Provide a succinct answer. 0.55. What is the ratio of the Aid flow from UN agencies (US$) of 1969 in Benin to that in Burkina Faso?
Make the answer very short. 0.88. What is the ratio of the Aid flow from UN agencies (US$) in 1971 in Benin to that in Burkina Faso?
Provide a succinct answer. 1.18. What is the ratio of the Aid flow from UN agencies (US$) in 1972 in Benin to that in Burkina Faso?
Make the answer very short. 5.44. What is the ratio of the Aid flow from UN agencies (US$) of 1969 in Bolivia to that in Burkina Faso?
Provide a short and direct response. 0.88. What is the ratio of the Aid flow from UN agencies (US$) of 1970 in Bolivia to that in Burkina Faso?
Offer a very short reply. 0.89. What is the ratio of the Aid flow from UN agencies (US$) of 1971 in Bolivia to that in Burkina Faso?
Your answer should be very brief. 2.16. What is the difference between the highest and the second highest Aid flow from UN agencies (US$) of 1969?
Offer a very short reply. 3.34e+07. What is the difference between the highest and the second highest Aid flow from UN agencies (US$) of 1970?
Provide a succinct answer. 6.87e+07. What is the difference between the highest and the second highest Aid flow from UN agencies (US$) of 1971?
Offer a very short reply. 9.25e+07. What is the difference between the highest and the second highest Aid flow from UN agencies (US$) of 1972?
Provide a succinct answer. 8.43e+07. What is the difference between the highest and the lowest Aid flow from UN agencies (US$) of 1969?
Make the answer very short. 6.44e+07. What is the difference between the highest and the lowest Aid flow from UN agencies (US$) of 1970?
Provide a short and direct response. 1.07e+08. What is the difference between the highest and the lowest Aid flow from UN agencies (US$) in 1971?
Your answer should be compact. 1.43e+08. What is the difference between the highest and the lowest Aid flow from UN agencies (US$) of 1972?
Make the answer very short. 1.25e+08. 